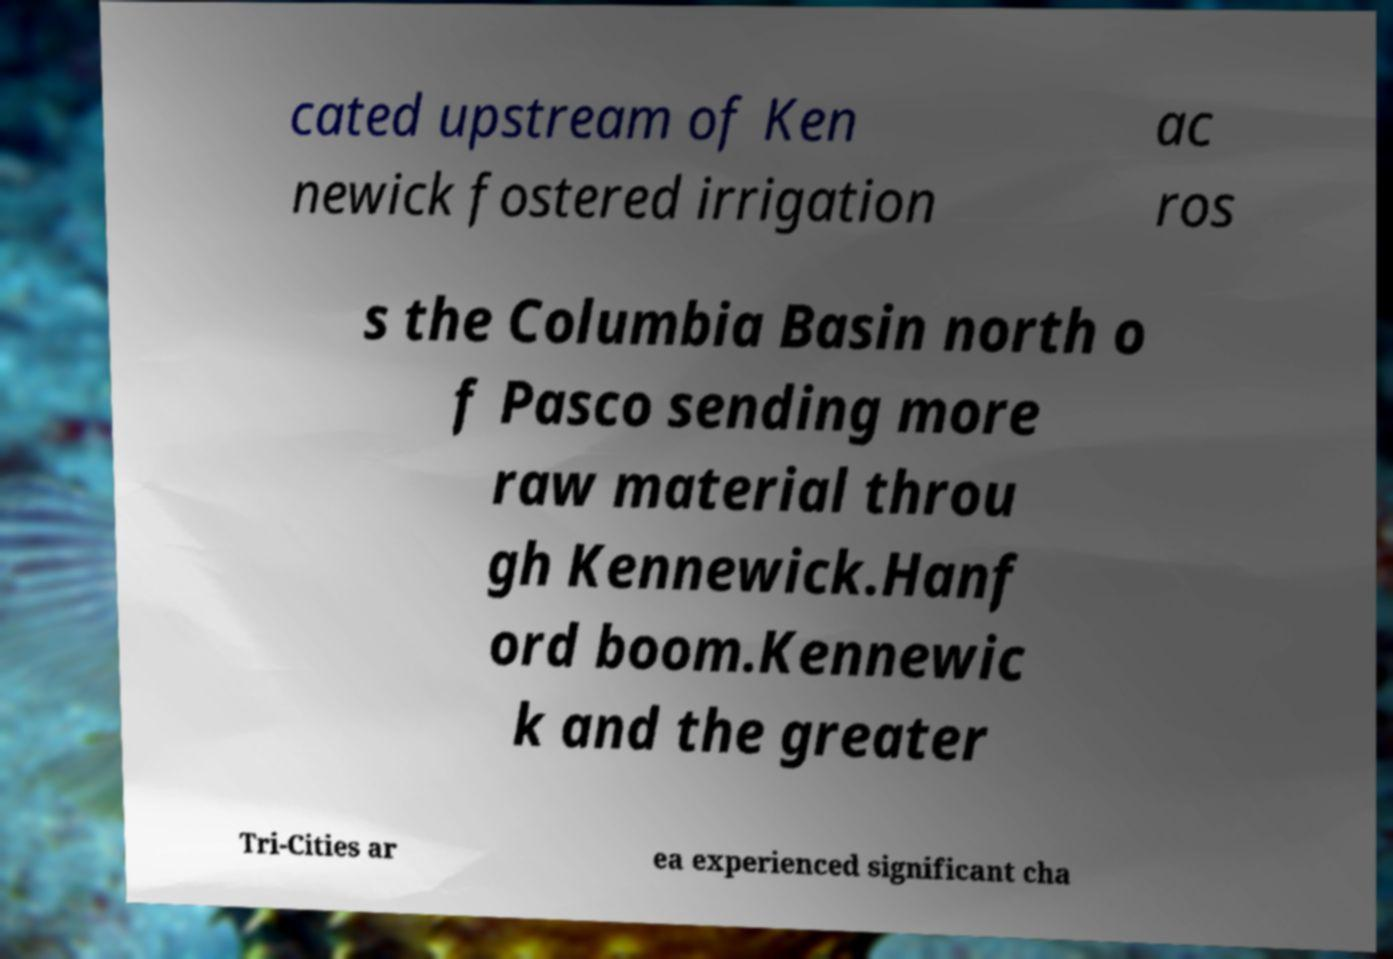For documentation purposes, I need the text within this image transcribed. Could you provide that? cated upstream of Ken newick fostered irrigation ac ros s the Columbia Basin north o f Pasco sending more raw material throu gh Kennewick.Hanf ord boom.Kennewic k and the greater Tri-Cities ar ea experienced significant cha 